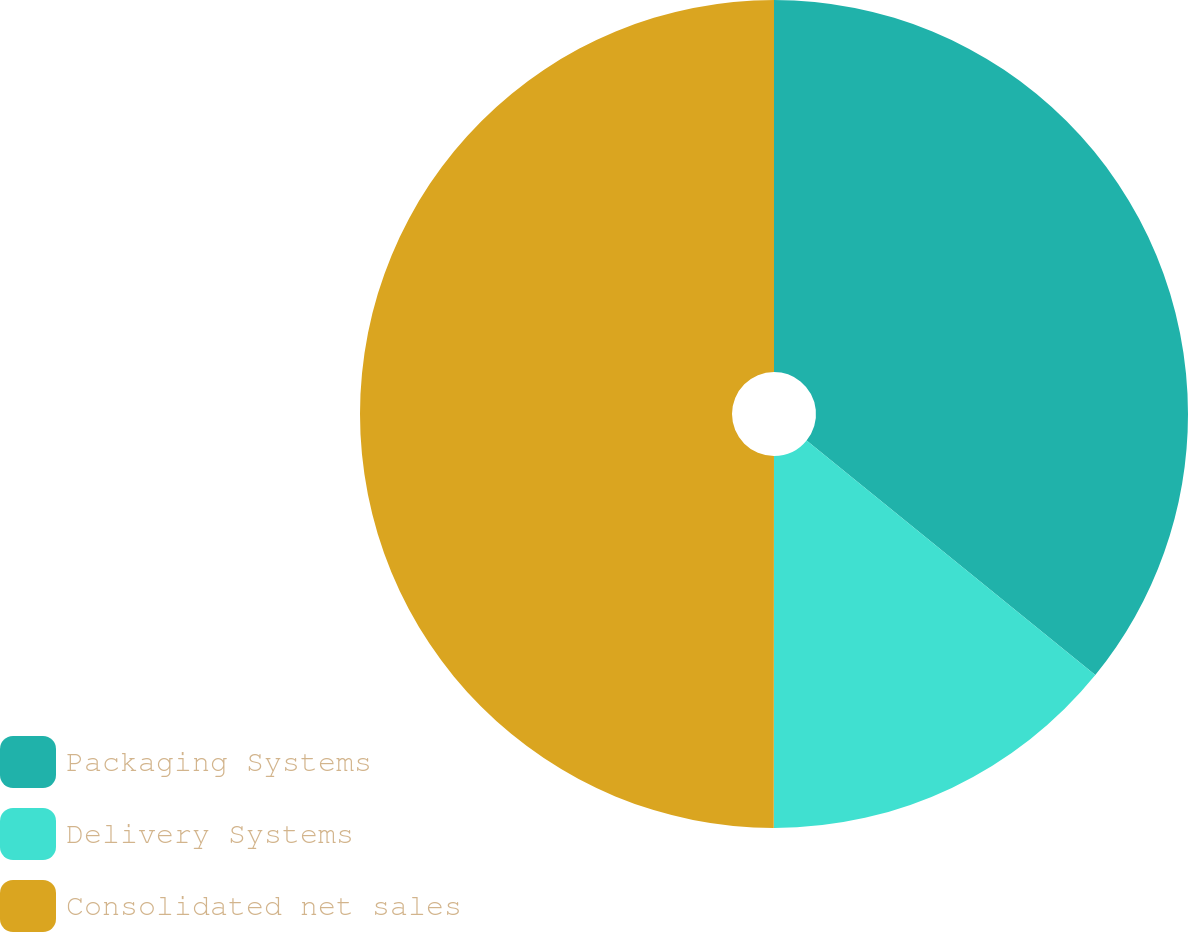<chart> <loc_0><loc_0><loc_500><loc_500><pie_chart><fcel>Packaging Systems<fcel>Delivery Systems<fcel>Consolidated net sales<nl><fcel>35.86%<fcel>14.15%<fcel>49.99%<nl></chart> 